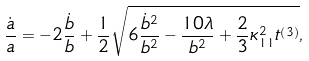<formula> <loc_0><loc_0><loc_500><loc_500>\frac { \dot { a } } { a } = - 2 \frac { \dot { b } } { b } + \frac { 1 } { 2 } \sqrt { 6 \frac { \dot { b } ^ { 2 } } { b ^ { 2 } } - \frac { 1 0 \lambda } { b ^ { 2 } } + \frac { 2 } { 3 } \kappa _ { 1 1 } ^ { 2 } t ^ { \left ( 3 \right ) } } ,</formula> 